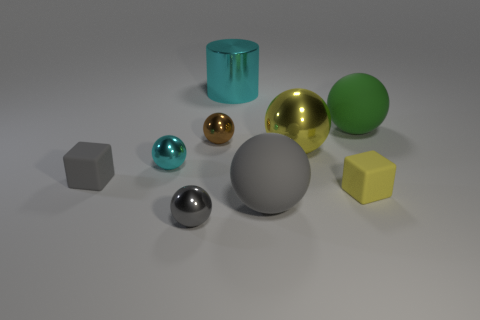Subtract 1 spheres. How many spheres are left? 5 Subtract all brown balls. How many balls are left? 5 Subtract all small cyan shiny spheres. How many spheres are left? 5 Subtract all cyan balls. Subtract all purple blocks. How many balls are left? 5 Add 1 tiny yellow cubes. How many objects exist? 10 Subtract all blocks. How many objects are left? 7 Add 2 large metal balls. How many large metal balls are left? 3 Add 5 brown shiny objects. How many brown shiny objects exist? 6 Subtract 0 purple cylinders. How many objects are left? 9 Subtract all big gray rubber things. Subtract all large rubber objects. How many objects are left? 6 